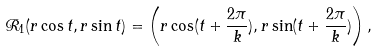Convert formula to latex. <formula><loc_0><loc_0><loc_500><loc_500>\mathcal { R } _ { 1 } ( r \cos t , r \sin t ) = \left ( r \cos ( t + \frac { 2 \pi } k ) , r \sin ( t + \frac { 2 \pi } k ) \right ) ,</formula> 